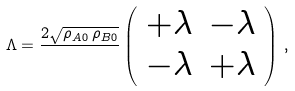<formula> <loc_0><loc_0><loc_500><loc_500>\Lambda = \frac { 2 \sqrt { \rho _ { A 0 } \, \rho _ { B 0 } } } { } \left ( \begin{array} { r r } + \lambda & - \lambda \\ - \lambda & + \lambda \\ \end{array} \right ) \, ,</formula> 